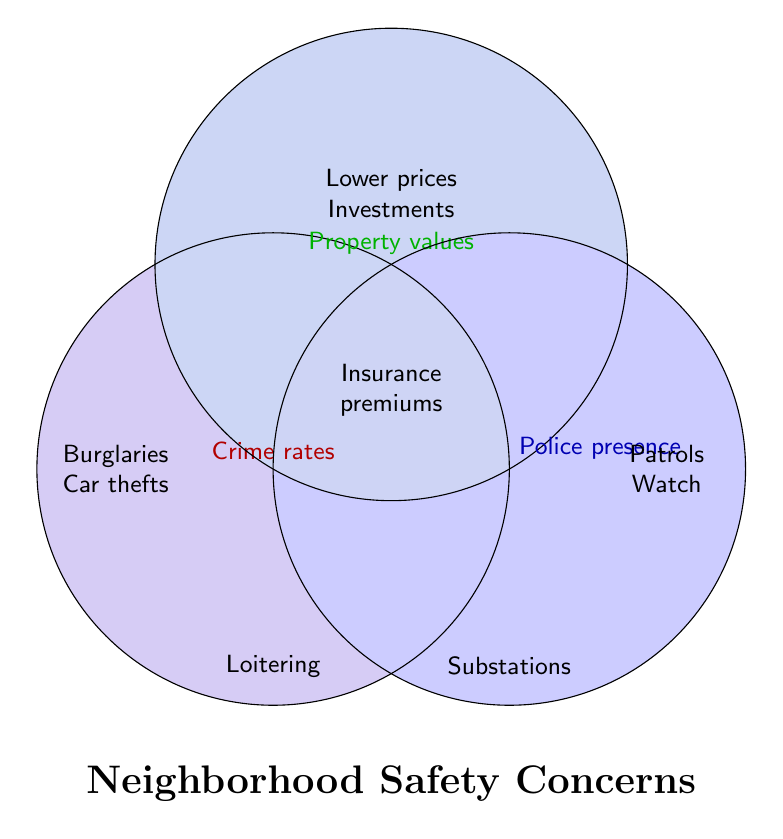What are some of the concerns listed under Crime rates? Crime rates circle includes increased burglaries, vandalism reports, car thefts, loitering concerns, and drug-related incidents.
Answer: Burglaries, Car thefts, Loitering, Drug-related incidents What are the key concerns affecting Property values? Property values circle lists lower home prices, reduced business investments, difficulty selling properties, and insurance premium increases.
Answer: Lower prices, Investments, Difficulty selling properties, Insurance premiums Which elements are exclusively under Police presence? Police presence circle includes more patrol cars, community policing programs, neighborhood watch initiatives, and police substations.
Answer: Patrols, Watch, Substations Which area in the Venn Diagram represents "Insurance premiums"? Insurance premiums are where the circles Crime rates and Property values overlap.
Answer: Overlap of Crime rates and Property values What is common between Crime rates and Property values but not in Police presence? Areas where Crime rates and Property values overlap but not Police presence include insurance premium increases.
Answer: Insurance premiums What are the combined concerns involving all three categories: Crime rates, Property values, and Police presence? The center area where all three circles overlap would list concerns involving all three.
Answer: None listed How does "Lower prices" relate to the other categories? Lower prices relate to Property values circle, but there's no additional overlapping concern listed with either Crime rates or Police presence.
Answer: Relates to Property values only Identify which concerns are associated with "Car thefts". Car thefts are positioned within the Crime rates circle.
Answer: Crime rates Which category(ies) does the concern "Substations" belong to? Substations are associated with Police presence.
Answer: Police presence 